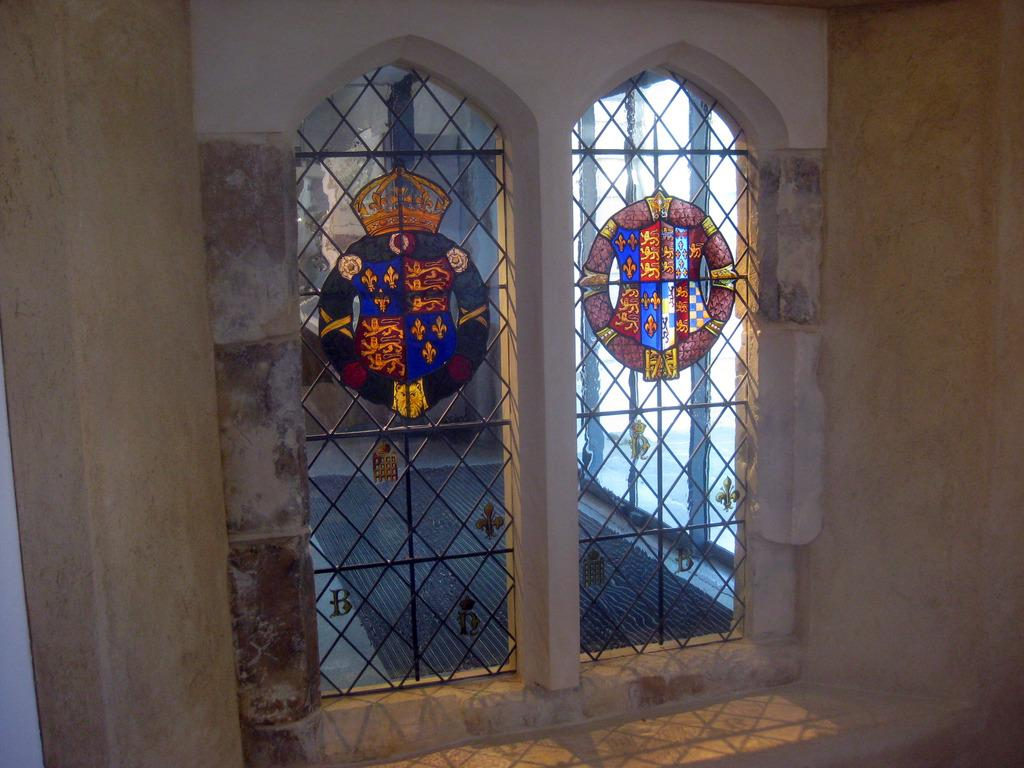What type of artwork can be seen on the windows in the image? There are windows with glass paintings in the image. What material are the grilles made of in the image? There are iron grilles in the image. Can you describe any other objects present in the image? There are other objects present in the image, but their specific details are not mentioned in the provided facts. Can you see a plough at the seashore in the image? There is no mention of a plough or a seashore in the provided facts, so we cannot answer this question based on the image. 